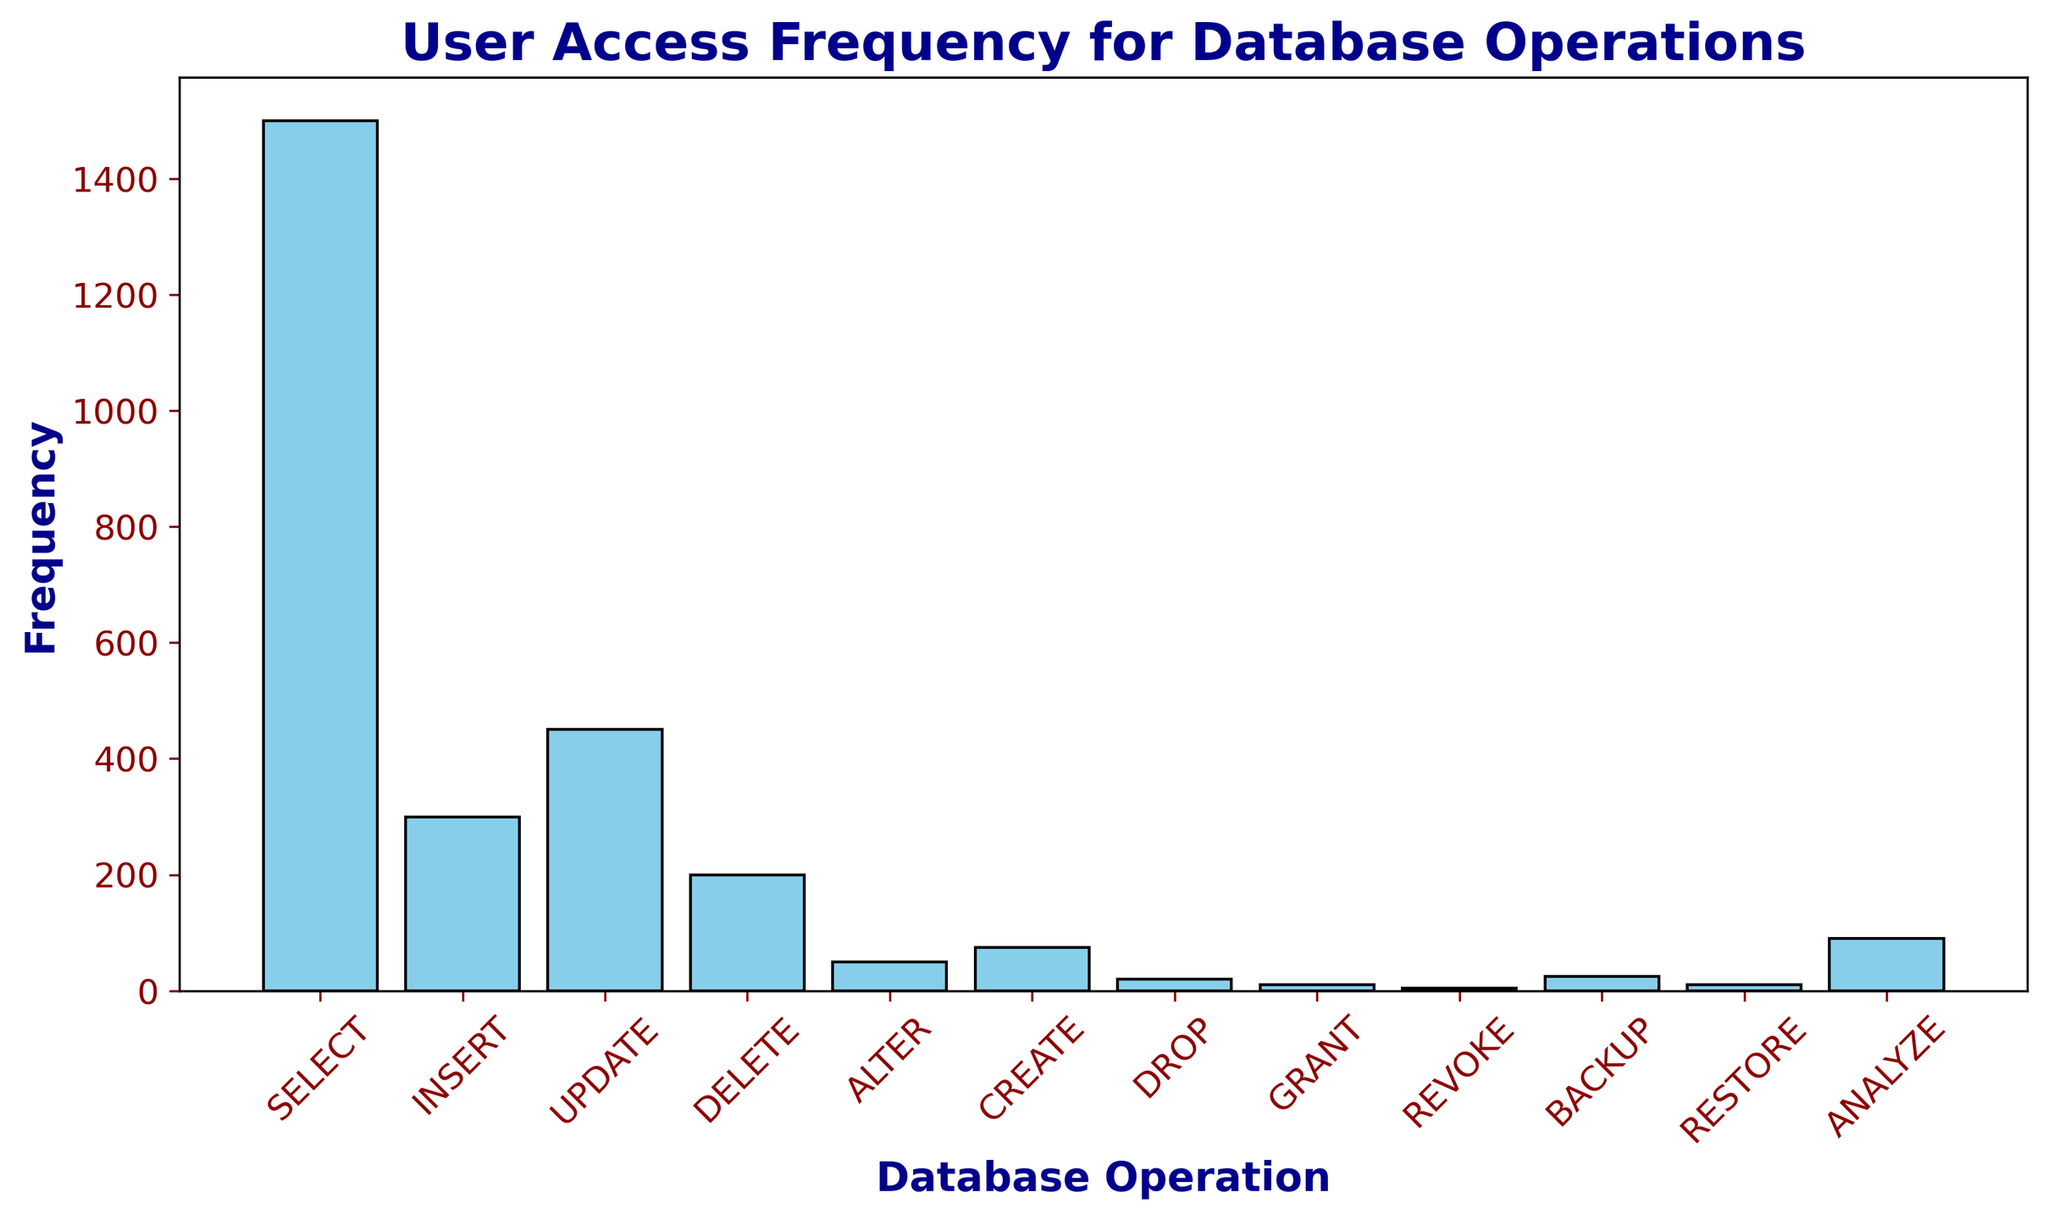Which database operation has the highest frequency? The database operation with the highest frequency can be identified by looking at the tallest bar in the histogram. The SELECT operation has the tallest bar.
Answer: SELECT Which database operation has the lowest frequency? The database operation with the lowest frequency can be identified by looking at the shortest bar in the histogram. The REVOKE operation has the shortest bar.
Answer: REVOKE How many more times is the SELECT operation used compared to the INSERT operation? The frequency of the SELECT operation is 1500 and the frequency of the INSERT operation is 300. The difference is found by subtracting the frequency of INSERT from the frequency of SELECT (1500 - 300).
Answer: 1200 What is the combined frequency of DELETE, BACKUP, and RESTORE operations? The frequencies of DELETE, BACKUP, and RESTORE are 200, 25, and 10, respectively. Summing these frequencies gives the combined frequency (200 + 25 +10).
Answer: 235 What is the average frequency of the CREATE, ALTER, and ANALYZE operations? The frequencies of CREATE, ALTER, and ANALYZE are 75, 50, and 90, respectively. The average frequency is calculated by summing these frequencies and dividing by the number of operations ((75 + 50 + 90) / 3).
Answer: 71.67 Which operations have frequencies less than 100? Operations with frequencies less than 100 can be identified by looking at the bars that are shorter than the one corresponding to 100 on the y-axis. These operations are ALTER, CREATE, DROP, GRANT, REVOKE, BACKUP, RESTORE, and ANALYZE.
Answer: ALTER, CREATE, DROP, GRANT, REVOKE, BACKUP, RESTORE, ANALYZE What is the frequency difference between INSERT and UPDATE operations? The frequency of the INSERT operation is 300 and the frequency of the UPDATE operation is 450. The difference is found by subtracting the frequency of INSERT from the frequency of UPDATE (450 - 300).
Answer: 150 Which operations have a frequency higher than 50 but lower than 200? Operations whose bars fall between the heights representing 50 and 200 on the y-axis should be identified. These operations are INSERT (300), UPDATE (450), and DELETE (200), which are slightly above and below this range. However, only ANALYZE fits exactly (90).
Answer: ANALYZE What is the median frequency of all the operations? To find the median frequency, first, order the frequencies: 5, 10, 10, 20, 25, 50, 75, 90, 200, 300, 450, 1500. With 12 data points, the median is the average of the 6th and 7th values (50 and 75).
Answer: 62.5 